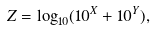<formula> <loc_0><loc_0><loc_500><loc_500>Z = \log _ { 1 0 } ( 1 0 ^ { X } + 1 0 ^ { Y } ) ,</formula> 